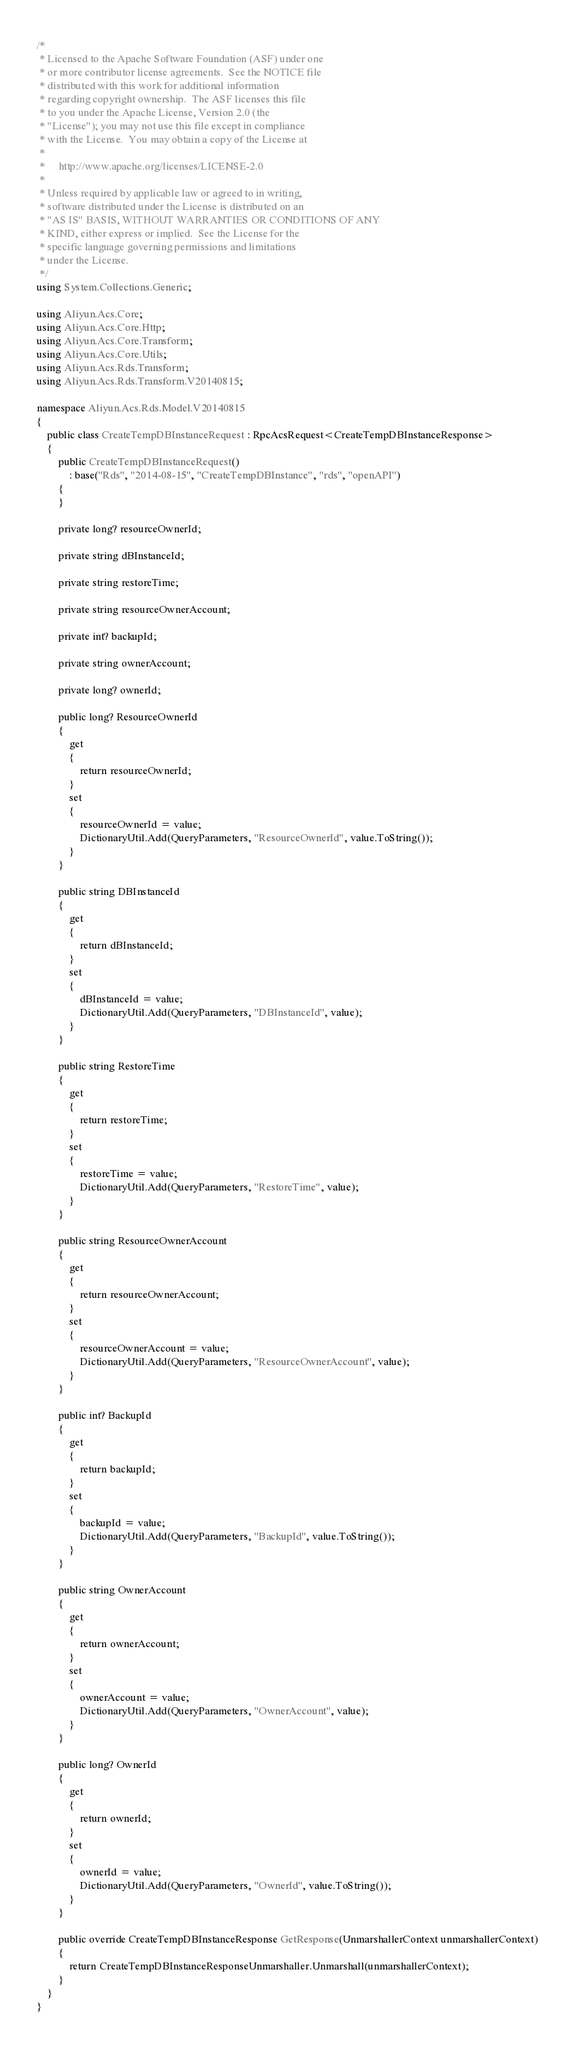Convert code to text. <code><loc_0><loc_0><loc_500><loc_500><_C#_>/*
 * Licensed to the Apache Software Foundation (ASF) under one
 * or more contributor license agreements.  See the NOTICE file
 * distributed with this work for additional information
 * regarding copyright ownership.  The ASF licenses this file
 * to you under the Apache License, Version 2.0 (the
 * "License"); you may not use this file except in compliance
 * with the License.  You may obtain a copy of the License at
 *
 *     http://www.apache.org/licenses/LICENSE-2.0
 *
 * Unless required by applicable law or agreed to in writing,
 * software distributed under the License is distributed on an
 * "AS IS" BASIS, WITHOUT WARRANTIES OR CONDITIONS OF ANY
 * KIND, either express or implied.  See the License for the
 * specific language governing permissions and limitations
 * under the License.
 */
using System.Collections.Generic;

using Aliyun.Acs.Core;
using Aliyun.Acs.Core.Http;
using Aliyun.Acs.Core.Transform;
using Aliyun.Acs.Core.Utils;
using Aliyun.Acs.Rds.Transform;
using Aliyun.Acs.Rds.Transform.V20140815;

namespace Aliyun.Acs.Rds.Model.V20140815
{
    public class CreateTempDBInstanceRequest : RpcAcsRequest<CreateTempDBInstanceResponse>
    {
        public CreateTempDBInstanceRequest()
            : base("Rds", "2014-08-15", "CreateTempDBInstance", "rds", "openAPI")
        {
        }

		private long? resourceOwnerId;

		private string dBInstanceId;

		private string restoreTime;

		private string resourceOwnerAccount;

		private int? backupId;

		private string ownerAccount;

		private long? ownerId;

		public long? ResourceOwnerId
		{
			get
			{
				return resourceOwnerId;
			}
			set	
			{
				resourceOwnerId = value;
				DictionaryUtil.Add(QueryParameters, "ResourceOwnerId", value.ToString());
			}
		}

		public string DBInstanceId
		{
			get
			{
				return dBInstanceId;
			}
			set	
			{
				dBInstanceId = value;
				DictionaryUtil.Add(QueryParameters, "DBInstanceId", value);
			}
		}

		public string RestoreTime
		{
			get
			{
				return restoreTime;
			}
			set	
			{
				restoreTime = value;
				DictionaryUtil.Add(QueryParameters, "RestoreTime", value);
			}
		}

		public string ResourceOwnerAccount
		{
			get
			{
				return resourceOwnerAccount;
			}
			set	
			{
				resourceOwnerAccount = value;
				DictionaryUtil.Add(QueryParameters, "ResourceOwnerAccount", value);
			}
		}

		public int? BackupId
		{
			get
			{
				return backupId;
			}
			set	
			{
				backupId = value;
				DictionaryUtil.Add(QueryParameters, "BackupId", value.ToString());
			}
		}

		public string OwnerAccount
		{
			get
			{
				return ownerAccount;
			}
			set	
			{
				ownerAccount = value;
				DictionaryUtil.Add(QueryParameters, "OwnerAccount", value);
			}
		}

		public long? OwnerId
		{
			get
			{
				return ownerId;
			}
			set	
			{
				ownerId = value;
				DictionaryUtil.Add(QueryParameters, "OwnerId", value.ToString());
			}
		}

        public override CreateTempDBInstanceResponse GetResponse(UnmarshallerContext unmarshallerContext)
        {
            return CreateTempDBInstanceResponseUnmarshaller.Unmarshall(unmarshallerContext);
        }
    }
}
</code> 